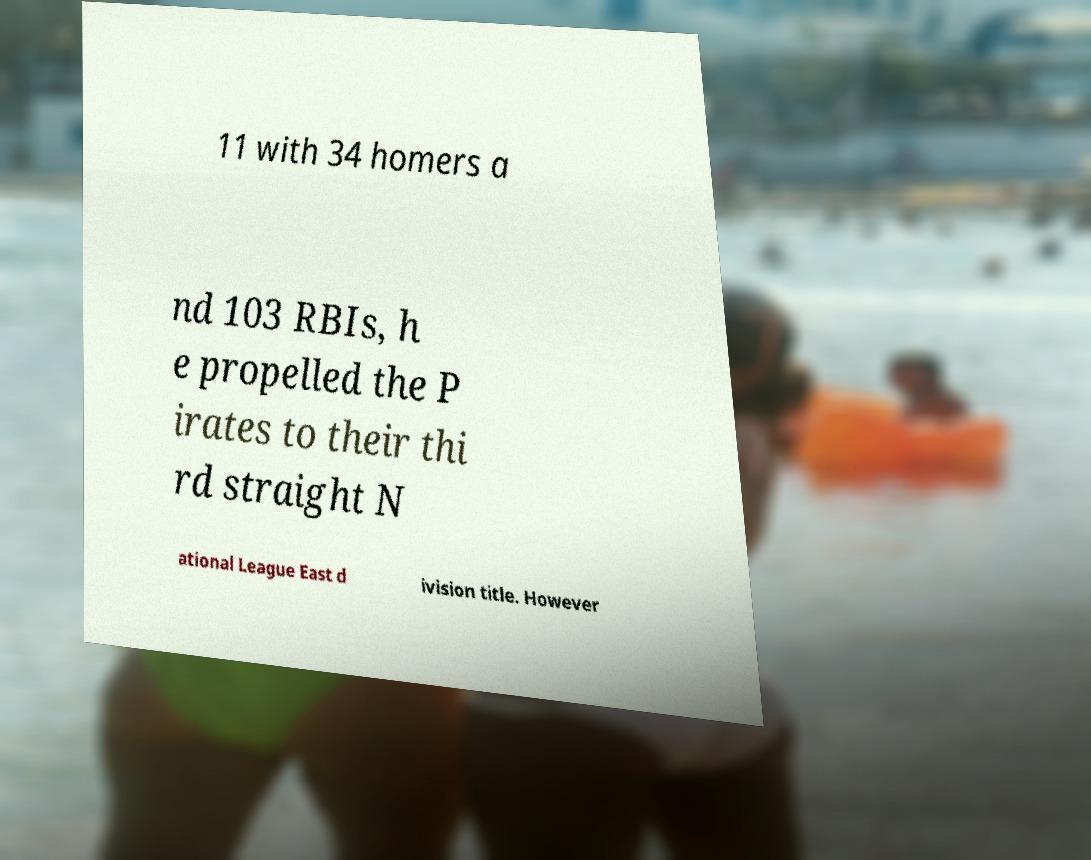Please identify and transcribe the text found in this image. 11 with 34 homers a nd 103 RBIs, h e propelled the P irates to their thi rd straight N ational League East d ivision title. However 